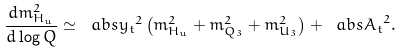<formula> <loc_0><loc_0><loc_500><loc_500>\frac { d m ^ { 2 } _ { H _ { u } } } { d \log { Q } } \simeq \ a b s { y _ { t } } ^ { 2 } \left ( m ^ { 2 } _ { H _ { u } } + m ^ { 2 } _ { Q _ { 3 } } + m ^ { 2 } _ { U _ { 3 } } \right ) + \ a b s { A _ { t } } ^ { 2 } .</formula> 